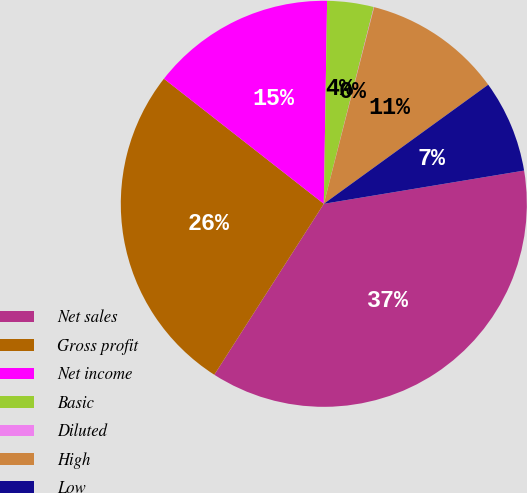Convert chart. <chart><loc_0><loc_0><loc_500><loc_500><pie_chart><fcel>Net sales<fcel>Gross profit<fcel>Net income<fcel>Basic<fcel>Diluted<fcel>High<fcel>Low<nl><fcel>36.68%<fcel>26.49%<fcel>14.69%<fcel>3.7%<fcel>0.03%<fcel>11.03%<fcel>7.36%<nl></chart> 